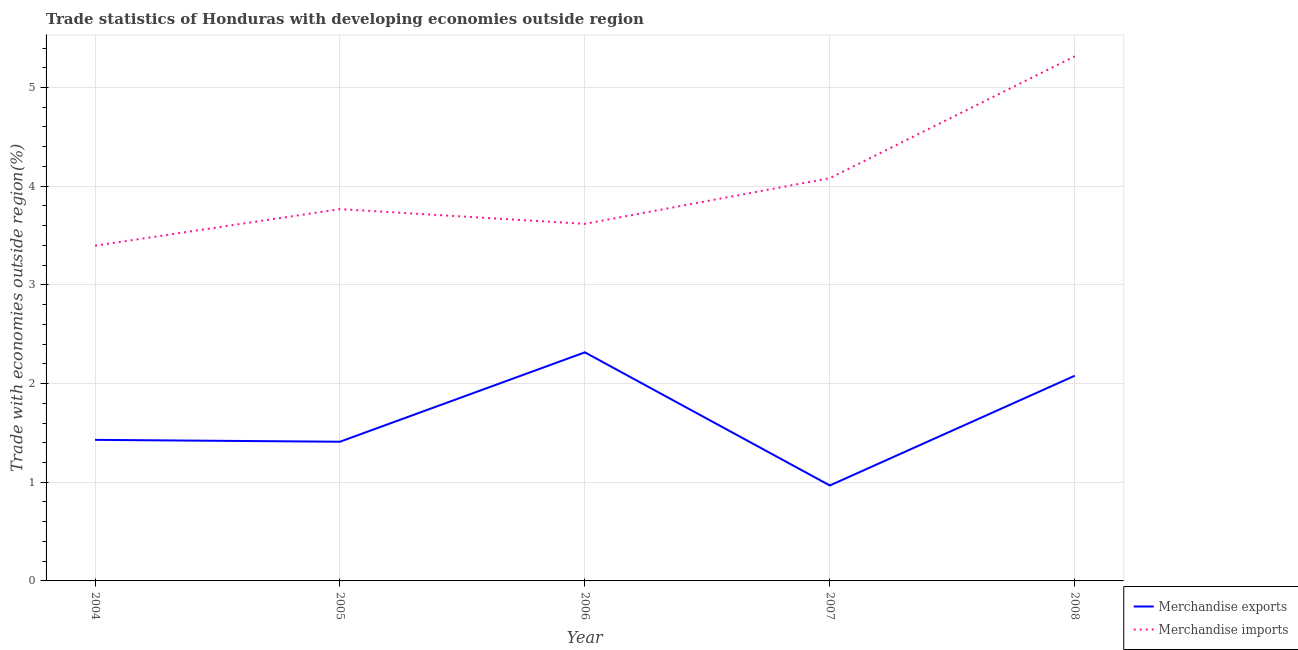Does the line corresponding to merchandise imports intersect with the line corresponding to merchandise exports?
Offer a terse response. No. What is the merchandise imports in 2006?
Your answer should be very brief. 3.62. Across all years, what is the maximum merchandise exports?
Your answer should be compact. 2.32. Across all years, what is the minimum merchandise imports?
Provide a succinct answer. 3.4. In which year was the merchandise exports maximum?
Provide a succinct answer. 2006. What is the total merchandise exports in the graph?
Provide a short and direct response. 8.2. What is the difference between the merchandise exports in 2004 and that in 2005?
Ensure brevity in your answer.  0.02. What is the difference between the merchandise imports in 2006 and the merchandise exports in 2005?
Offer a very short reply. 2.21. What is the average merchandise imports per year?
Offer a terse response. 4.04. In the year 2007, what is the difference between the merchandise exports and merchandise imports?
Keep it short and to the point. -3.11. In how many years, is the merchandise imports greater than 1.8 %?
Provide a succinct answer. 5. What is the ratio of the merchandise imports in 2005 to that in 2006?
Make the answer very short. 1.04. Is the merchandise exports in 2005 less than that in 2008?
Your answer should be compact. Yes. Is the difference between the merchandise exports in 2005 and 2006 greater than the difference between the merchandise imports in 2005 and 2006?
Provide a short and direct response. No. What is the difference between the highest and the second highest merchandise exports?
Your answer should be compact. 0.24. What is the difference between the highest and the lowest merchandise exports?
Your answer should be very brief. 1.35. Is the sum of the merchandise imports in 2006 and 2008 greater than the maximum merchandise exports across all years?
Make the answer very short. Yes. Does the merchandise exports monotonically increase over the years?
Provide a short and direct response. No. Is the merchandise imports strictly less than the merchandise exports over the years?
Your answer should be very brief. No. How many years are there in the graph?
Keep it short and to the point. 5. What is the title of the graph?
Ensure brevity in your answer.  Trade statistics of Honduras with developing economies outside region. Does "Merchandise imports" appear as one of the legend labels in the graph?
Offer a terse response. Yes. What is the label or title of the X-axis?
Your response must be concise. Year. What is the label or title of the Y-axis?
Keep it short and to the point. Trade with economies outside region(%). What is the Trade with economies outside region(%) of Merchandise exports in 2004?
Provide a succinct answer. 1.43. What is the Trade with economies outside region(%) in Merchandise imports in 2004?
Ensure brevity in your answer.  3.4. What is the Trade with economies outside region(%) of Merchandise exports in 2005?
Keep it short and to the point. 1.41. What is the Trade with economies outside region(%) of Merchandise imports in 2005?
Provide a short and direct response. 3.77. What is the Trade with economies outside region(%) of Merchandise exports in 2006?
Provide a succinct answer. 2.32. What is the Trade with economies outside region(%) in Merchandise imports in 2006?
Give a very brief answer. 3.62. What is the Trade with economies outside region(%) in Merchandise exports in 2007?
Provide a short and direct response. 0.97. What is the Trade with economies outside region(%) of Merchandise imports in 2007?
Provide a succinct answer. 4.08. What is the Trade with economies outside region(%) in Merchandise exports in 2008?
Offer a very short reply. 2.08. What is the Trade with economies outside region(%) of Merchandise imports in 2008?
Your answer should be very brief. 5.32. Across all years, what is the maximum Trade with economies outside region(%) of Merchandise exports?
Keep it short and to the point. 2.32. Across all years, what is the maximum Trade with economies outside region(%) in Merchandise imports?
Give a very brief answer. 5.32. Across all years, what is the minimum Trade with economies outside region(%) of Merchandise exports?
Your answer should be compact. 0.97. Across all years, what is the minimum Trade with economies outside region(%) in Merchandise imports?
Your response must be concise. 3.4. What is the total Trade with economies outside region(%) in Merchandise exports in the graph?
Make the answer very short. 8.2. What is the total Trade with economies outside region(%) in Merchandise imports in the graph?
Keep it short and to the point. 20.18. What is the difference between the Trade with economies outside region(%) of Merchandise exports in 2004 and that in 2005?
Your answer should be compact. 0.02. What is the difference between the Trade with economies outside region(%) of Merchandise imports in 2004 and that in 2005?
Make the answer very short. -0.37. What is the difference between the Trade with economies outside region(%) in Merchandise exports in 2004 and that in 2006?
Keep it short and to the point. -0.89. What is the difference between the Trade with economies outside region(%) of Merchandise imports in 2004 and that in 2006?
Provide a succinct answer. -0.22. What is the difference between the Trade with economies outside region(%) of Merchandise exports in 2004 and that in 2007?
Offer a very short reply. 0.46. What is the difference between the Trade with economies outside region(%) in Merchandise imports in 2004 and that in 2007?
Provide a succinct answer. -0.68. What is the difference between the Trade with economies outside region(%) in Merchandise exports in 2004 and that in 2008?
Give a very brief answer. -0.65. What is the difference between the Trade with economies outside region(%) in Merchandise imports in 2004 and that in 2008?
Ensure brevity in your answer.  -1.92. What is the difference between the Trade with economies outside region(%) in Merchandise exports in 2005 and that in 2006?
Your answer should be very brief. -0.91. What is the difference between the Trade with economies outside region(%) in Merchandise imports in 2005 and that in 2006?
Your answer should be very brief. 0.15. What is the difference between the Trade with economies outside region(%) in Merchandise exports in 2005 and that in 2007?
Your response must be concise. 0.44. What is the difference between the Trade with economies outside region(%) in Merchandise imports in 2005 and that in 2007?
Keep it short and to the point. -0.31. What is the difference between the Trade with economies outside region(%) of Merchandise exports in 2005 and that in 2008?
Make the answer very short. -0.67. What is the difference between the Trade with economies outside region(%) in Merchandise imports in 2005 and that in 2008?
Offer a very short reply. -1.55. What is the difference between the Trade with economies outside region(%) in Merchandise exports in 2006 and that in 2007?
Keep it short and to the point. 1.35. What is the difference between the Trade with economies outside region(%) in Merchandise imports in 2006 and that in 2007?
Give a very brief answer. -0.46. What is the difference between the Trade with economies outside region(%) of Merchandise exports in 2006 and that in 2008?
Keep it short and to the point. 0.24. What is the difference between the Trade with economies outside region(%) in Merchandise imports in 2006 and that in 2008?
Provide a succinct answer. -1.7. What is the difference between the Trade with economies outside region(%) in Merchandise exports in 2007 and that in 2008?
Your answer should be very brief. -1.11. What is the difference between the Trade with economies outside region(%) of Merchandise imports in 2007 and that in 2008?
Give a very brief answer. -1.23. What is the difference between the Trade with economies outside region(%) of Merchandise exports in 2004 and the Trade with economies outside region(%) of Merchandise imports in 2005?
Your answer should be very brief. -2.34. What is the difference between the Trade with economies outside region(%) in Merchandise exports in 2004 and the Trade with economies outside region(%) in Merchandise imports in 2006?
Your answer should be compact. -2.19. What is the difference between the Trade with economies outside region(%) of Merchandise exports in 2004 and the Trade with economies outside region(%) of Merchandise imports in 2007?
Make the answer very short. -2.65. What is the difference between the Trade with economies outside region(%) of Merchandise exports in 2004 and the Trade with economies outside region(%) of Merchandise imports in 2008?
Offer a very short reply. -3.89. What is the difference between the Trade with economies outside region(%) in Merchandise exports in 2005 and the Trade with economies outside region(%) in Merchandise imports in 2006?
Provide a succinct answer. -2.21. What is the difference between the Trade with economies outside region(%) of Merchandise exports in 2005 and the Trade with economies outside region(%) of Merchandise imports in 2007?
Keep it short and to the point. -2.67. What is the difference between the Trade with economies outside region(%) in Merchandise exports in 2005 and the Trade with economies outside region(%) in Merchandise imports in 2008?
Offer a terse response. -3.91. What is the difference between the Trade with economies outside region(%) in Merchandise exports in 2006 and the Trade with economies outside region(%) in Merchandise imports in 2007?
Offer a very short reply. -1.76. What is the difference between the Trade with economies outside region(%) in Merchandise exports in 2006 and the Trade with economies outside region(%) in Merchandise imports in 2008?
Ensure brevity in your answer.  -3. What is the difference between the Trade with economies outside region(%) of Merchandise exports in 2007 and the Trade with economies outside region(%) of Merchandise imports in 2008?
Give a very brief answer. -4.35. What is the average Trade with economies outside region(%) in Merchandise exports per year?
Keep it short and to the point. 1.64. What is the average Trade with economies outside region(%) of Merchandise imports per year?
Your answer should be compact. 4.04. In the year 2004, what is the difference between the Trade with economies outside region(%) of Merchandise exports and Trade with economies outside region(%) of Merchandise imports?
Your answer should be compact. -1.97. In the year 2005, what is the difference between the Trade with economies outside region(%) of Merchandise exports and Trade with economies outside region(%) of Merchandise imports?
Your answer should be very brief. -2.36. In the year 2006, what is the difference between the Trade with economies outside region(%) of Merchandise exports and Trade with economies outside region(%) of Merchandise imports?
Make the answer very short. -1.3. In the year 2007, what is the difference between the Trade with economies outside region(%) of Merchandise exports and Trade with economies outside region(%) of Merchandise imports?
Give a very brief answer. -3.11. In the year 2008, what is the difference between the Trade with economies outside region(%) in Merchandise exports and Trade with economies outside region(%) in Merchandise imports?
Ensure brevity in your answer.  -3.24. What is the ratio of the Trade with economies outside region(%) of Merchandise exports in 2004 to that in 2005?
Your answer should be compact. 1.01. What is the ratio of the Trade with economies outside region(%) in Merchandise imports in 2004 to that in 2005?
Offer a terse response. 0.9. What is the ratio of the Trade with economies outside region(%) of Merchandise exports in 2004 to that in 2006?
Ensure brevity in your answer.  0.62. What is the ratio of the Trade with economies outside region(%) in Merchandise imports in 2004 to that in 2006?
Your answer should be compact. 0.94. What is the ratio of the Trade with economies outside region(%) of Merchandise exports in 2004 to that in 2007?
Your answer should be very brief. 1.48. What is the ratio of the Trade with economies outside region(%) in Merchandise imports in 2004 to that in 2007?
Give a very brief answer. 0.83. What is the ratio of the Trade with economies outside region(%) of Merchandise exports in 2004 to that in 2008?
Provide a succinct answer. 0.69. What is the ratio of the Trade with economies outside region(%) of Merchandise imports in 2004 to that in 2008?
Keep it short and to the point. 0.64. What is the ratio of the Trade with economies outside region(%) in Merchandise exports in 2005 to that in 2006?
Offer a very short reply. 0.61. What is the ratio of the Trade with economies outside region(%) in Merchandise imports in 2005 to that in 2006?
Ensure brevity in your answer.  1.04. What is the ratio of the Trade with economies outside region(%) of Merchandise exports in 2005 to that in 2007?
Offer a terse response. 1.46. What is the ratio of the Trade with economies outside region(%) of Merchandise imports in 2005 to that in 2007?
Provide a succinct answer. 0.92. What is the ratio of the Trade with economies outside region(%) of Merchandise exports in 2005 to that in 2008?
Your answer should be very brief. 0.68. What is the ratio of the Trade with economies outside region(%) in Merchandise imports in 2005 to that in 2008?
Provide a succinct answer. 0.71. What is the ratio of the Trade with economies outside region(%) of Merchandise exports in 2006 to that in 2007?
Offer a very short reply. 2.39. What is the ratio of the Trade with economies outside region(%) of Merchandise imports in 2006 to that in 2007?
Give a very brief answer. 0.89. What is the ratio of the Trade with economies outside region(%) of Merchandise exports in 2006 to that in 2008?
Give a very brief answer. 1.11. What is the ratio of the Trade with economies outside region(%) of Merchandise imports in 2006 to that in 2008?
Keep it short and to the point. 0.68. What is the ratio of the Trade with economies outside region(%) of Merchandise exports in 2007 to that in 2008?
Provide a succinct answer. 0.47. What is the ratio of the Trade with economies outside region(%) of Merchandise imports in 2007 to that in 2008?
Ensure brevity in your answer.  0.77. What is the difference between the highest and the second highest Trade with economies outside region(%) in Merchandise exports?
Ensure brevity in your answer.  0.24. What is the difference between the highest and the second highest Trade with economies outside region(%) in Merchandise imports?
Offer a very short reply. 1.23. What is the difference between the highest and the lowest Trade with economies outside region(%) of Merchandise exports?
Ensure brevity in your answer.  1.35. What is the difference between the highest and the lowest Trade with economies outside region(%) in Merchandise imports?
Ensure brevity in your answer.  1.92. 